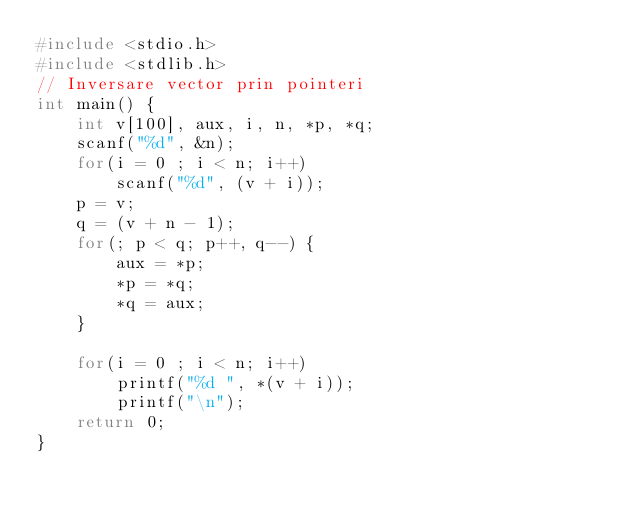Convert code to text. <code><loc_0><loc_0><loc_500><loc_500><_C_>#include <stdio.h>
#include <stdlib.h>
// Inversare vector prin pointeri
int main() {
	int v[100], aux, i, n, *p, *q;
	scanf("%d", &n);
	for(i = 0 ; i < n; i++)
		scanf("%d", (v + i));
	p = v;
	q = (v + n - 1);
	for(; p < q; p++, q--) {
		aux = *p;
		*p = *q;
		*q = aux;
	}

	for(i = 0 ; i < n; i++)
		printf("%d ", *(v + i));
		printf("\n");
	return 0;
}
</code> 